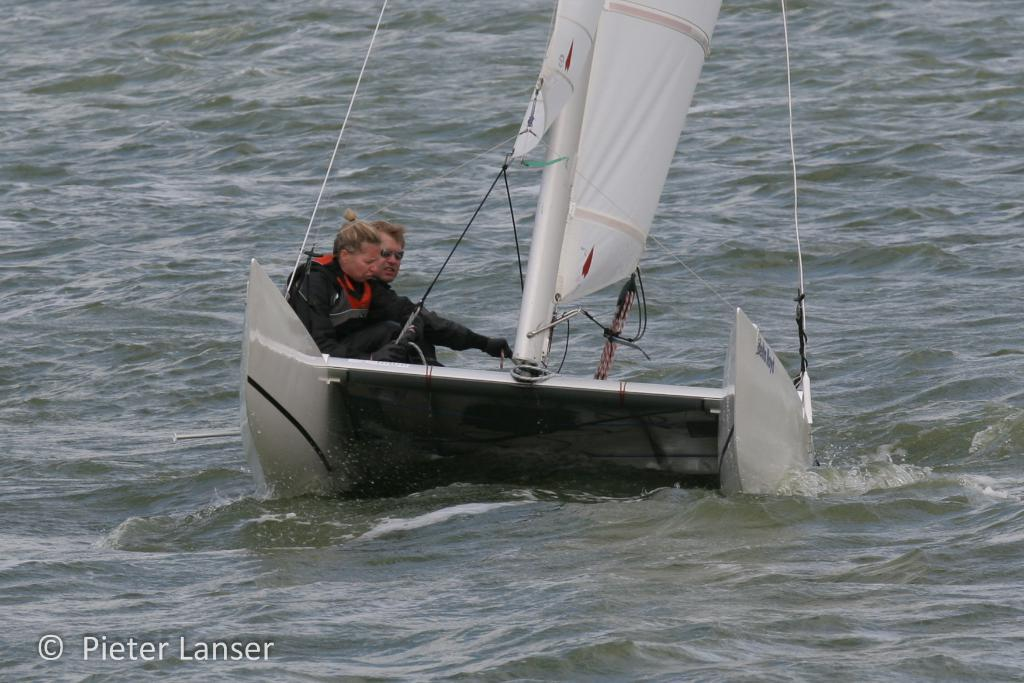Who is present in the image? There is a woman and a man in the image. What are they doing in the image? They are sailing a boat. Where is the boat located? The boat is on the water. What can be seen in the image that is related to the boat's operation? There are ropes and a pole visible in the image. What type of meal is being prepared on the boat in the image? There is no meal preparation visible in the image; the focus is on the sailing activity. Can you tell me how many shoes the woman is wearing in the image? There is no information about shoes or footwear in the image; the focus is on the sailing activity and the boat's features. 